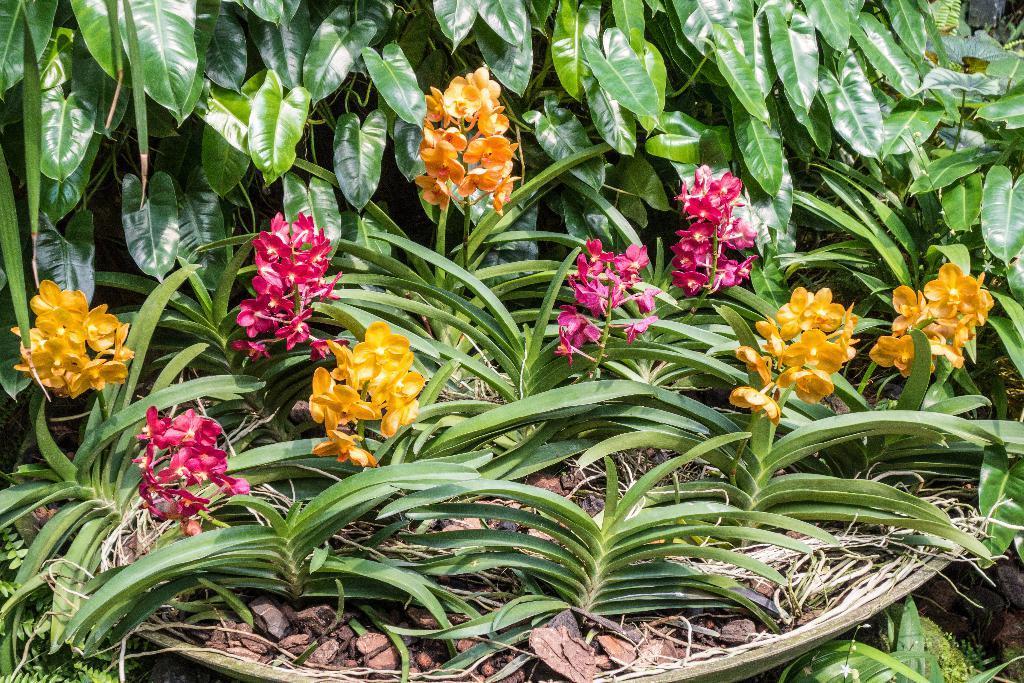Could you give a brief overview of what you see in this image? In this image I can see a basket in which there are yellow and pink flower plants. There are leaves at the back. 